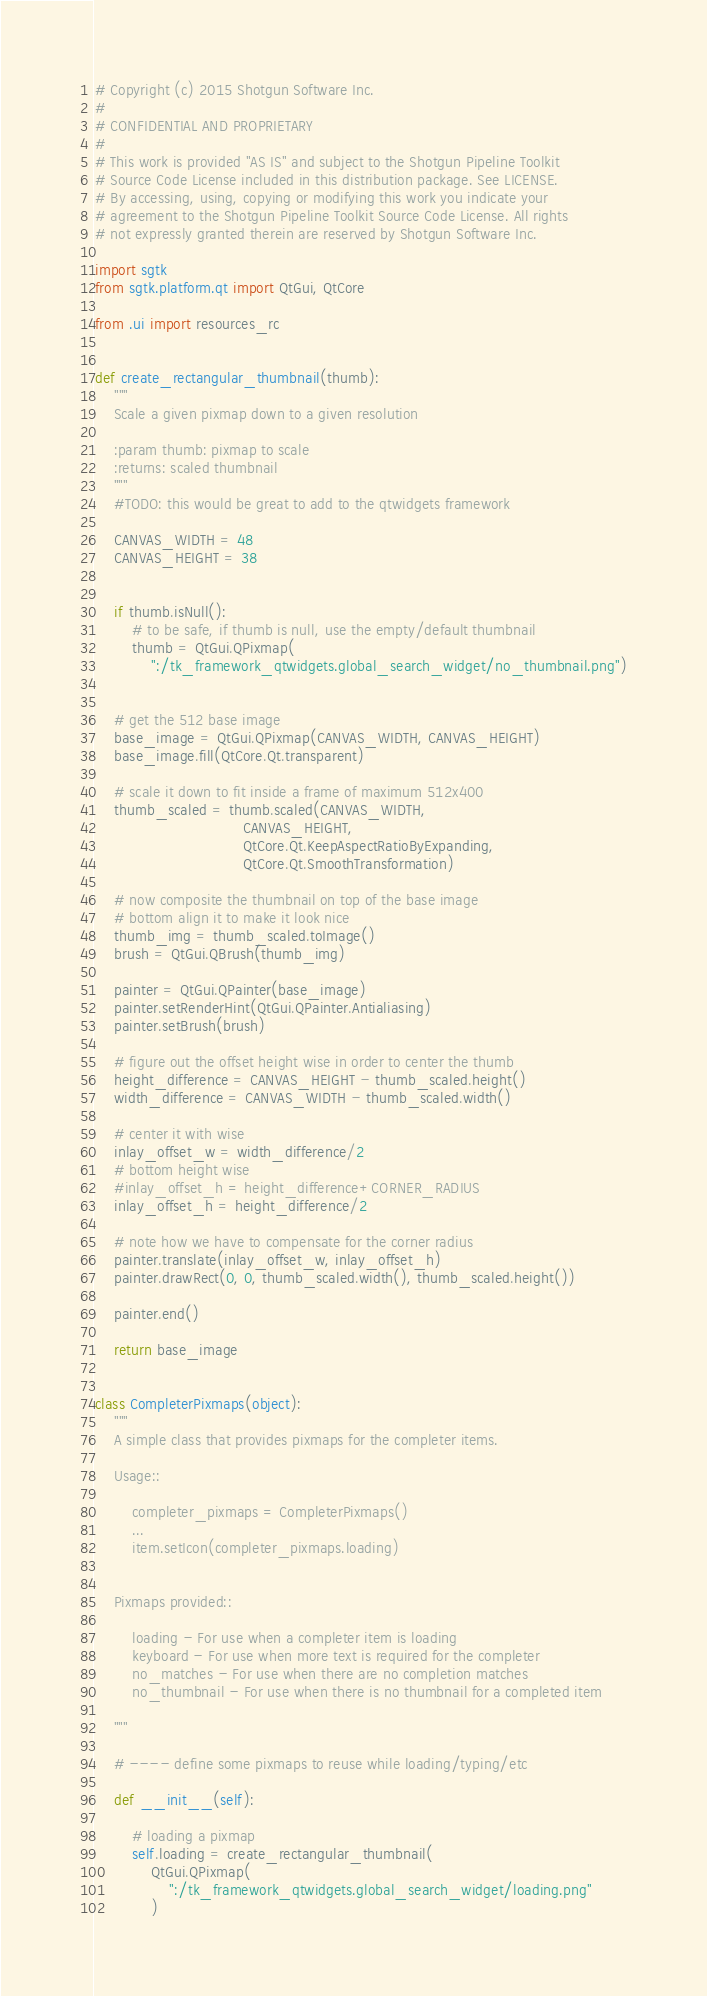<code> <loc_0><loc_0><loc_500><loc_500><_Python_># Copyright (c) 2015 Shotgun Software Inc.
#
# CONFIDENTIAL AND PROPRIETARY
#
# This work is provided "AS IS" and subject to the Shotgun Pipeline Toolkit
# Source Code License included in this distribution package. See LICENSE.
# By accessing, using, copying or modifying this work you indicate your
# agreement to the Shotgun Pipeline Toolkit Source Code License. All rights
# not expressly granted therein are reserved by Shotgun Software Inc.

import sgtk
from sgtk.platform.qt import QtGui, QtCore

from .ui import resources_rc


def create_rectangular_thumbnail(thumb):
    """
    Scale a given pixmap down to a given resolution

    :param thumb: pixmap to scale
    :returns: scaled thumbnail
    """
    #TODO: this would be great to add to the qtwidgets framework

    CANVAS_WIDTH = 48
    CANVAS_HEIGHT = 38


    if thumb.isNull():
        # to be safe, if thumb is null, use the empty/default thumbnail
        thumb = QtGui.QPixmap(
            ":/tk_framework_qtwidgets.global_search_widget/no_thumbnail.png")


    # get the 512 base image
    base_image = QtGui.QPixmap(CANVAS_WIDTH, CANVAS_HEIGHT)
    base_image.fill(QtCore.Qt.transparent)

    # scale it down to fit inside a frame of maximum 512x400
    thumb_scaled = thumb.scaled(CANVAS_WIDTH,
                                CANVAS_HEIGHT,
                                QtCore.Qt.KeepAspectRatioByExpanding,
                                QtCore.Qt.SmoothTransformation)

    # now composite the thumbnail on top of the base image
    # bottom align it to make it look nice
    thumb_img = thumb_scaled.toImage()
    brush = QtGui.QBrush(thumb_img)

    painter = QtGui.QPainter(base_image)
    painter.setRenderHint(QtGui.QPainter.Antialiasing)
    painter.setBrush(brush)

    # figure out the offset height wise in order to center the thumb
    height_difference = CANVAS_HEIGHT - thumb_scaled.height()
    width_difference = CANVAS_WIDTH - thumb_scaled.width()

    # center it with wise
    inlay_offset_w = width_difference/2
    # bottom height wise
    #inlay_offset_h = height_difference+CORNER_RADIUS
    inlay_offset_h = height_difference/2

    # note how we have to compensate for the corner radius
    painter.translate(inlay_offset_w, inlay_offset_h)
    painter.drawRect(0, 0, thumb_scaled.width(), thumb_scaled.height())

    painter.end()

    return base_image


class CompleterPixmaps(object):
    """
    A simple class that provides pixmaps for the completer items.

    Usage::

        completer_pixmaps = CompleterPixmaps()
        ...
        item.setIcon(completer_pixmaps.loading)


    Pixmaps provided::

        loading - For use when a completer item is loading
        keyboard - For use when more text is required for the completer
        no_matches - For use when there are no completion matches
        no_thumbnail - For use when there is no thumbnail for a completed item

    """

    # ---- define some pixmaps to reuse while loading/typing/etc

    def __init__(self):

        # loading a pixmap
        self.loading = create_rectangular_thumbnail(
            QtGui.QPixmap(
                ":/tk_framework_qtwidgets.global_search_widget/loading.png"
            )</code> 